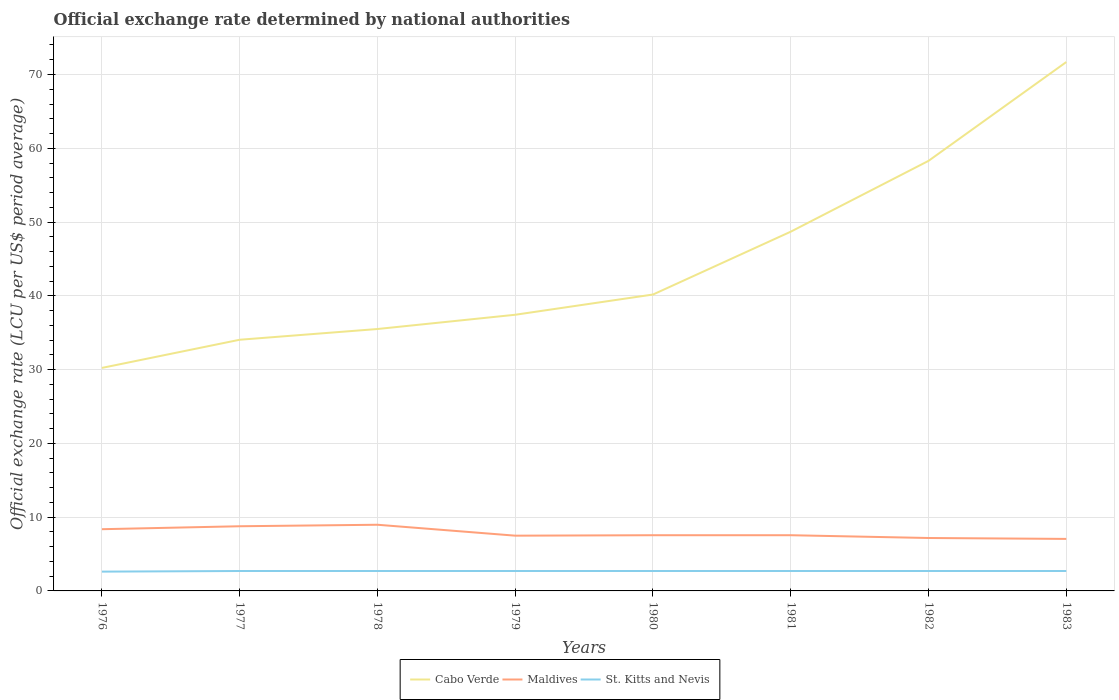Does the line corresponding to Cabo Verde intersect with the line corresponding to St. Kitts and Nevis?
Keep it short and to the point. No. Is the number of lines equal to the number of legend labels?
Your response must be concise. Yes. Across all years, what is the maximum official exchange rate in Cabo Verde?
Your answer should be very brief. 30.23. In which year was the official exchange rate in St. Kitts and Nevis maximum?
Make the answer very short. 1976. What is the total official exchange rate in St. Kitts and Nevis in the graph?
Your response must be concise. 0. What is the difference between the highest and the second highest official exchange rate in Maldives?
Ensure brevity in your answer.  1.92. What is the difference between the highest and the lowest official exchange rate in Maldives?
Offer a very short reply. 3. Are the values on the major ticks of Y-axis written in scientific E-notation?
Keep it short and to the point. No. Does the graph contain grids?
Make the answer very short. Yes. How many legend labels are there?
Provide a short and direct response. 3. What is the title of the graph?
Provide a short and direct response. Official exchange rate determined by national authorities. What is the label or title of the Y-axis?
Provide a succinct answer. Official exchange rate (LCU per US$ period average). What is the Official exchange rate (LCU per US$ period average) of Cabo Verde in 1976?
Give a very brief answer. 30.23. What is the Official exchange rate (LCU per US$ period average) in Maldives in 1976?
Keep it short and to the point. 8.36. What is the Official exchange rate (LCU per US$ period average) in St. Kitts and Nevis in 1976?
Offer a very short reply. 2.61. What is the Official exchange rate (LCU per US$ period average) of Cabo Verde in 1977?
Provide a short and direct response. 34.05. What is the Official exchange rate (LCU per US$ period average) in Maldives in 1977?
Provide a short and direct response. 8.77. What is the Official exchange rate (LCU per US$ period average) of Cabo Verde in 1978?
Offer a very short reply. 35.5. What is the Official exchange rate (LCU per US$ period average) in Maldives in 1978?
Your answer should be very brief. 8.97. What is the Official exchange rate (LCU per US$ period average) of Cabo Verde in 1979?
Keep it short and to the point. 37.43. What is the Official exchange rate (LCU per US$ period average) of Maldives in 1979?
Provide a short and direct response. 7.49. What is the Official exchange rate (LCU per US$ period average) of St. Kitts and Nevis in 1979?
Offer a very short reply. 2.7. What is the Official exchange rate (LCU per US$ period average) in Cabo Verde in 1980?
Your answer should be very brief. 40.17. What is the Official exchange rate (LCU per US$ period average) in Maldives in 1980?
Provide a succinct answer. 7.55. What is the Official exchange rate (LCU per US$ period average) of Cabo Verde in 1981?
Provide a succinct answer. 48.69. What is the Official exchange rate (LCU per US$ period average) in Maldives in 1981?
Make the answer very short. 7.55. What is the Official exchange rate (LCU per US$ period average) in St. Kitts and Nevis in 1981?
Your answer should be compact. 2.7. What is the Official exchange rate (LCU per US$ period average) of Cabo Verde in 1982?
Your answer should be compact. 58.29. What is the Official exchange rate (LCU per US$ period average) in Maldives in 1982?
Make the answer very short. 7.17. What is the Official exchange rate (LCU per US$ period average) of St. Kitts and Nevis in 1982?
Keep it short and to the point. 2.7. What is the Official exchange rate (LCU per US$ period average) in Cabo Verde in 1983?
Your response must be concise. 71.69. What is the Official exchange rate (LCU per US$ period average) in Maldives in 1983?
Provide a short and direct response. 7.05. What is the Official exchange rate (LCU per US$ period average) of St. Kitts and Nevis in 1983?
Keep it short and to the point. 2.7. Across all years, what is the maximum Official exchange rate (LCU per US$ period average) of Cabo Verde?
Give a very brief answer. 71.69. Across all years, what is the maximum Official exchange rate (LCU per US$ period average) in Maldives?
Provide a short and direct response. 8.97. Across all years, what is the minimum Official exchange rate (LCU per US$ period average) in Cabo Verde?
Give a very brief answer. 30.23. Across all years, what is the minimum Official exchange rate (LCU per US$ period average) in Maldives?
Provide a succinct answer. 7.05. Across all years, what is the minimum Official exchange rate (LCU per US$ period average) of St. Kitts and Nevis?
Give a very brief answer. 2.61. What is the total Official exchange rate (LCU per US$ period average) in Cabo Verde in the graph?
Ensure brevity in your answer.  356.06. What is the total Official exchange rate (LCU per US$ period average) of Maldives in the graph?
Your answer should be compact. 62.91. What is the total Official exchange rate (LCU per US$ period average) in St. Kitts and Nevis in the graph?
Make the answer very short. 21.51. What is the difference between the Official exchange rate (LCU per US$ period average) in Cabo Verde in 1976 and that in 1977?
Keep it short and to the point. -3.82. What is the difference between the Official exchange rate (LCU per US$ period average) of Maldives in 1976 and that in 1977?
Ensure brevity in your answer.  -0.4. What is the difference between the Official exchange rate (LCU per US$ period average) in St. Kitts and Nevis in 1976 and that in 1977?
Offer a terse response. -0.09. What is the difference between the Official exchange rate (LCU per US$ period average) in Cabo Verde in 1976 and that in 1978?
Your answer should be very brief. -5.27. What is the difference between the Official exchange rate (LCU per US$ period average) of Maldives in 1976 and that in 1978?
Provide a succinct answer. -0.6. What is the difference between the Official exchange rate (LCU per US$ period average) of St. Kitts and Nevis in 1976 and that in 1978?
Give a very brief answer. -0.09. What is the difference between the Official exchange rate (LCU per US$ period average) of Cabo Verde in 1976 and that in 1979?
Offer a very short reply. -7.2. What is the difference between the Official exchange rate (LCU per US$ period average) of Maldives in 1976 and that in 1979?
Make the answer very short. 0.88. What is the difference between the Official exchange rate (LCU per US$ period average) of St. Kitts and Nevis in 1976 and that in 1979?
Your response must be concise. -0.09. What is the difference between the Official exchange rate (LCU per US$ period average) in Cabo Verde in 1976 and that in 1980?
Your response must be concise. -9.95. What is the difference between the Official exchange rate (LCU per US$ period average) in Maldives in 1976 and that in 1980?
Provide a succinct answer. 0.81. What is the difference between the Official exchange rate (LCU per US$ period average) of St. Kitts and Nevis in 1976 and that in 1980?
Make the answer very short. -0.09. What is the difference between the Official exchange rate (LCU per US$ period average) of Cabo Verde in 1976 and that in 1981?
Your answer should be very brief. -18.47. What is the difference between the Official exchange rate (LCU per US$ period average) in Maldives in 1976 and that in 1981?
Offer a very short reply. 0.81. What is the difference between the Official exchange rate (LCU per US$ period average) of St. Kitts and Nevis in 1976 and that in 1981?
Ensure brevity in your answer.  -0.09. What is the difference between the Official exchange rate (LCU per US$ period average) of Cabo Verde in 1976 and that in 1982?
Make the answer very short. -28.06. What is the difference between the Official exchange rate (LCU per US$ period average) of Maldives in 1976 and that in 1982?
Provide a short and direct response. 1.19. What is the difference between the Official exchange rate (LCU per US$ period average) of St. Kitts and Nevis in 1976 and that in 1982?
Offer a terse response. -0.09. What is the difference between the Official exchange rate (LCU per US$ period average) in Cabo Verde in 1976 and that in 1983?
Provide a short and direct response. -41.46. What is the difference between the Official exchange rate (LCU per US$ period average) in Maldives in 1976 and that in 1983?
Your response must be concise. 1.31. What is the difference between the Official exchange rate (LCU per US$ period average) in St. Kitts and Nevis in 1976 and that in 1983?
Your answer should be very brief. -0.09. What is the difference between the Official exchange rate (LCU per US$ period average) in Cabo Verde in 1977 and that in 1978?
Give a very brief answer. -1.45. What is the difference between the Official exchange rate (LCU per US$ period average) of Maldives in 1977 and that in 1978?
Make the answer very short. -0.2. What is the difference between the Official exchange rate (LCU per US$ period average) of St. Kitts and Nevis in 1977 and that in 1978?
Keep it short and to the point. 0. What is the difference between the Official exchange rate (LCU per US$ period average) in Cabo Verde in 1977 and that in 1979?
Provide a succinct answer. -3.39. What is the difference between the Official exchange rate (LCU per US$ period average) of Maldives in 1977 and that in 1979?
Your answer should be compact. 1.28. What is the difference between the Official exchange rate (LCU per US$ period average) in Cabo Verde in 1977 and that in 1980?
Your answer should be compact. -6.13. What is the difference between the Official exchange rate (LCU per US$ period average) in Maldives in 1977 and that in 1980?
Ensure brevity in your answer.  1.22. What is the difference between the Official exchange rate (LCU per US$ period average) in St. Kitts and Nevis in 1977 and that in 1980?
Your answer should be compact. 0. What is the difference between the Official exchange rate (LCU per US$ period average) of Cabo Verde in 1977 and that in 1981?
Your response must be concise. -14.65. What is the difference between the Official exchange rate (LCU per US$ period average) in Maldives in 1977 and that in 1981?
Give a very brief answer. 1.22. What is the difference between the Official exchange rate (LCU per US$ period average) of St. Kitts and Nevis in 1977 and that in 1981?
Keep it short and to the point. 0. What is the difference between the Official exchange rate (LCU per US$ period average) in Cabo Verde in 1977 and that in 1982?
Provide a short and direct response. -24.25. What is the difference between the Official exchange rate (LCU per US$ period average) in Maldives in 1977 and that in 1982?
Give a very brief answer. 1.59. What is the difference between the Official exchange rate (LCU per US$ period average) of Cabo Verde in 1977 and that in 1983?
Provide a short and direct response. -37.64. What is the difference between the Official exchange rate (LCU per US$ period average) in Maldives in 1977 and that in 1983?
Your answer should be very brief. 1.72. What is the difference between the Official exchange rate (LCU per US$ period average) in Cabo Verde in 1978 and that in 1979?
Offer a terse response. -1.93. What is the difference between the Official exchange rate (LCU per US$ period average) in Maldives in 1978 and that in 1979?
Provide a short and direct response. 1.48. What is the difference between the Official exchange rate (LCU per US$ period average) of St. Kitts and Nevis in 1978 and that in 1979?
Your response must be concise. 0. What is the difference between the Official exchange rate (LCU per US$ period average) in Cabo Verde in 1978 and that in 1980?
Keep it short and to the point. -4.67. What is the difference between the Official exchange rate (LCU per US$ period average) of Maldives in 1978 and that in 1980?
Your answer should be compact. 1.42. What is the difference between the Official exchange rate (LCU per US$ period average) of Cabo Verde in 1978 and that in 1981?
Offer a terse response. -13.19. What is the difference between the Official exchange rate (LCU per US$ period average) of Maldives in 1978 and that in 1981?
Provide a short and direct response. 1.42. What is the difference between the Official exchange rate (LCU per US$ period average) in St. Kitts and Nevis in 1978 and that in 1981?
Your answer should be compact. 0. What is the difference between the Official exchange rate (LCU per US$ period average) of Cabo Verde in 1978 and that in 1982?
Offer a very short reply. -22.79. What is the difference between the Official exchange rate (LCU per US$ period average) of Maldives in 1978 and that in 1982?
Your response must be concise. 1.8. What is the difference between the Official exchange rate (LCU per US$ period average) in St. Kitts and Nevis in 1978 and that in 1982?
Offer a terse response. 0. What is the difference between the Official exchange rate (LCU per US$ period average) of Cabo Verde in 1978 and that in 1983?
Give a very brief answer. -36.19. What is the difference between the Official exchange rate (LCU per US$ period average) of Maldives in 1978 and that in 1983?
Your answer should be compact. 1.92. What is the difference between the Official exchange rate (LCU per US$ period average) in St. Kitts and Nevis in 1978 and that in 1983?
Your response must be concise. 0. What is the difference between the Official exchange rate (LCU per US$ period average) in Cabo Verde in 1979 and that in 1980?
Ensure brevity in your answer.  -2.74. What is the difference between the Official exchange rate (LCU per US$ period average) of Maldives in 1979 and that in 1980?
Your answer should be compact. -0.06. What is the difference between the Official exchange rate (LCU per US$ period average) of Cabo Verde in 1979 and that in 1981?
Keep it short and to the point. -11.26. What is the difference between the Official exchange rate (LCU per US$ period average) in Maldives in 1979 and that in 1981?
Your response must be concise. -0.06. What is the difference between the Official exchange rate (LCU per US$ period average) of St. Kitts and Nevis in 1979 and that in 1981?
Provide a succinct answer. 0. What is the difference between the Official exchange rate (LCU per US$ period average) of Cabo Verde in 1979 and that in 1982?
Provide a short and direct response. -20.86. What is the difference between the Official exchange rate (LCU per US$ period average) of Maldives in 1979 and that in 1982?
Keep it short and to the point. 0.31. What is the difference between the Official exchange rate (LCU per US$ period average) in St. Kitts and Nevis in 1979 and that in 1982?
Keep it short and to the point. 0. What is the difference between the Official exchange rate (LCU per US$ period average) in Cabo Verde in 1979 and that in 1983?
Provide a succinct answer. -34.25. What is the difference between the Official exchange rate (LCU per US$ period average) of Maldives in 1979 and that in 1983?
Your answer should be very brief. 0.44. What is the difference between the Official exchange rate (LCU per US$ period average) of Cabo Verde in 1980 and that in 1981?
Ensure brevity in your answer.  -8.52. What is the difference between the Official exchange rate (LCU per US$ period average) of Maldives in 1980 and that in 1981?
Make the answer very short. 0. What is the difference between the Official exchange rate (LCU per US$ period average) of Cabo Verde in 1980 and that in 1982?
Provide a succinct answer. -18.12. What is the difference between the Official exchange rate (LCU per US$ period average) in Maldives in 1980 and that in 1982?
Your answer should be very brief. 0.38. What is the difference between the Official exchange rate (LCU per US$ period average) of St. Kitts and Nevis in 1980 and that in 1982?
Offer a terse response. 0. What is the difference between the Official exchange rate (LCU per US$ period average) in Cabo Verde in 1980 and that in 1983?
Your response must be concise. -31.51. What is the difference between the Official exchange rate (LCU per US$ period average) in Cabo Verde in 1981 and that in 1982?
Keep it short and to the point. -9.6. What is the difference between the Official exchange rate (LCU per US$ period average) of Maldives in 1981 and that in 1982?
Offer a terse response. 0.38. What is the difference between the Official exchange rate (LCU per US$ period average) of Cabo Verde in 1981 and that in 1983?
Keep it short and to the point. -22.99. What is the difference between the Official exchange rate (LCU per US$ period average) of Maldives in 1981 and that in 1983?
Give a very brief answer. 0.5. What is the difference between the Official exchange rate (LCU per US$ period average) in St. Kitts and Nevis in 1981 and that in 1983?
Make the answer very short. 0. What is the difference between the Official exchange rate (LCU per US$ period average) in Cabo Verde in 1982 and that in 1983?
Give a very brief answer. -13.39. What is the difference between the Official exchange rate (LCU per US$ period average) of Maldives in 1982 and that in 1983?
Your answer should be compact. 0.12. What is the difference between the Official exchange rate (LCU per US$ period average) of St. Kitts and Nevis in 1982 and that in 1983?
Your response must be concise. 0. What is the difference between the Official exchange rate (LCU per US$ period average) in Cabo Verde in 1976 and the Official exchange rate (LCU per US$ period average) in Maldives in 1977?
Keep it short and to the point. 21.46. What is the difference between the Official exchange rate (LCU per US$ period average) of Cabo Verde in 1976 and the Official exchange rate (LCU per US$ period average) of St. Kitts and Nevis in 1977?
Make the answer very short. 27.53. What is the difference between the Official exchange rate (LCU per US$ period average) in Maldives in 1976 and the Official exchange rate (LCU per US$ period average) in St. Kitts and Nevis in 1977?
Your answer should be compact. 5.66. What is the difference between the Official exchange rate (LCU per US$ period average) in Cabo Verde in 1976 and the Official exchange rate (LCU per US$ period average) in Maldives in 1978?
Your answer should be very brief. 21.26. What is the difference between the Official exchange rate (LCU per US$ period average) of Cabo Verde in 1976 and the Official exchange rate (LCU per US$ period average) of St. Kitts and Nevis in 1978?
Offer a terse response. 27.53. What is the difference between the Official exchange rate (LCU per US$ period average) in Maldives in 1976 and the Official exchange rate (LCU per US$ period average) in St. Kitts and Nevis in 1978?
Your answer should be very brief. 5.66. What is the difference between the Official exchange rate (LCU per US$ period average) in Cabo Verde in 1976 and the Official exchange rate (LCU per US$ period average) in Maldives in 1979?
Make the answer very short. 22.74. What is the difference between the Official exchange rate (LCU per US$ period average) in Cabo Verde in 1976 and the Official exchange rate (LCU per US$ period average) in St. Kitts and Nevis in 1979?
Ensure brevity in your answer.  27.53. What is the difference between the Official exchange rate (LCU per US$ period average) of Maldives in 1976 and the Official exchange rate (LCU per US$ period average) of St. Kitts and Nevis in 1979?
Ensure brevity in your answer.  5.66. What is the difference between the Official exchange rate (LCU per US$ period average) in Cabo Verde in 1976 and the Official exchange rate (LCU per US$ period average) in Maldives in 1980?
Offer a terse response. 22.68. What is the difference between the Official exchange rate (LCU per US$ period average) in Cabo Verde in 1976 and the Official exchange rate (LCU per US$ period average) in St. Kitts and Nevis in 1980?
Your response must be concise. 27.53. What is the difference between the Official exchange rate (LCU per US$ period average) in Maldives in 1976 and the Official exchange rate (LCU per US$ period average) in St. Kitts and Nevis in 1980?
Offer a very short reply. 5.66. What is the difference between the Official exchange rate (LCU per US$ period average) of Cabo Verde in 1976 and the Official exchange rate (LCU per US$ period average) of Maldives in 1981?
Provide a short and direct response. 22.68. What is the difference between the Official exchange rate (LCU per US$ period average) of Cabo Verde in 1976 and the Official exchange rate (LCU per US$ period average) of St. Kitts and Nevis in 1981?
Offer a terse response. 27.53. What is the difference between the Official exchange rate (LCU per US$ period average) of Maldives in 1976 and the Official exchange rate (LCU per US$ period average) of St. Kitts and Nevis in 1981?
Make the answer very short. 5.66. What is the difference between the Official exchange rate (LCU per US$ period average) in Cabo Verde in 1976 and the Official exchange rate (LCU per US$ period average) in Maldives in 1982?
Ensure brevity in your answer.  23.06. What is the difference between the Official exchange rate (LCU per US$ period average) of Cabo Verde in 1976 and the Official exchange rate (LCU per US$ period average) of St. Kitts and Nevis in 1982?
Provide a succinct answer. 27.53. What is the difference between the Official exchange rate (LCU per US$ period average) of Maldives in 1976 and the Official exchange rate (LCU per US$ period average) of St. Kitts and Nevis in 1982?
Your response must be concise. 5.66. What is the difference between the Official exchange rate (LCU per US$ period average) of Cabo Verde in 1976 and the Official exchange rate (LCU per US$ period average) of Maldives in 1983?
Ensure brevity in your answer.  23.18. What is the difference between the Official exchange rate (LCU per US$ period average) of Cabo Verde in 1976 and the Official exchange rate (LCU per US$ period average) of St. Kitts and Nevis in 1983?
Offer a very short reply. 27.53. What is the difference between the Official exchange rate (LCU per US$ period average) in Maldives in 1976 and the Official exchange rate (LCU per US$ period average) in St. Kitts and Nevis in 1983?
Keep it short and to the point. 5.66. What is the difference between the Official exchange rate (LCU per US$ period average) of Cabo Verde in 1977 and the Official exchange rate (LCU per US$ period average) of Maldives in 1978?
Ensure brevity in your answer.  25.08. What is the difference between the Official exchange rate (LCU per US$ period average) of Cabo Verde in 1977 and the Official exchange rate (LCU per US$ period average) of St. Kitts and Nevis in 1978?
Provide a succinct answer. 31.35. What is the difference between the Official exchange rate (LCU per US$ period average) in Maldives in 1977 and the Official exchange rate (LCU per US$ period average) in St. Kitts and Nevis in 1978?
Your answer should be very brief. 6.07. What is the difference between the Official exchange rate (LCU per US$ period average) of Cabo Verde in 1977 and the Official exchange rate (LCU per US$ period average) of Maldives in 1979?
Keep it short and to the point. 26.56. What is the difference between the Official exchange rate (LCU per US$ period average) in Cabo Verde in 1977 and the Official exchange rate (LCU per US$ period average) in St. Kitts and Nevis in 1979?
Give a very brief answer. 31.35. What is the difference between the Official exchange rate (LCU per US$ period average) in Maldives in 1977 and the Official exchange rate (LCU per US$ period average) in St. Kitts and Nevis in 1979?
Provide a succinct answer. 6.07. What is the difference between the Official exchange rate (LCU per US$ period average) in Cabo Verde in 1977 and the Official exchange rate (LCU per US$ period average) in Maldives in 1980?
Give a very brief answer. 26.5. What is the difference between the Official exchange rate (LCU per US$ period average) in Cabo Verde in 1977 and the Official exchange rate (LCU per US$ period average) in St. Kitts and Nevis in 1980?
Ensure brevity in your answer.  31.35. What is the difference between the Official exchange rate (LCU per US$ period average) in Maldives in 1977 and the Official exchange rate (LCU per US$ period average) in St. Kitts and Nevis in 1980?
Provide a succinct answer. 6.07. What is the difference between the Official exchange rate (LCU per US$ period average) of Cabo Verde in 1977 and the Official exchange rate (LCU per US$ period average) of Maldives in 1981?
Give a very brief answer. 26.5. What is the difference between the Official exchange rate (LCU per US$ period average) of Cabo Verde in 1977 and the Official exchange rate (LCU per US$ period average) of St. Kitts and Nevis in 1981?
Make the answer very short. 31.35. What is the difference between the Official exchange rate (LCU per US$ period average) of Maldives in 1977 and the Official exchange rate (LCU per US$ period average) of St. Kitts and Nevis in 1981?
Offer a very short reply. 6.07. What is the difference between the Official exchange rate (LCU per US$ period average) in Cabo Verde in 1977 and the Official exchange rate (LCU per US$ period average) in Maldives in 1982?
Your answer should be very brief. 26.87. What is the difference between the Official exchange rate (LCU per US$ period average) in Cabo Verde in 1977 and the Official exchange rate (LCU per US$ period average) in St. Kitts and Nevis in 1982?
Give a very brief answer. 31.35. What is the difference between the Official exchange rate (LCU per US$ period average) in Maldives in 1977 and the Official exchange rate (LCU per US$ period average) in St. Kitts and Nevis in 1982?
Provide a succinct answer. 6.07. What is the difference between the Official exchange rate (LCU per US$ period average) of Cabo Verde in 1977 and the Official exchange rate (LCU per US$ period average) of Maldives in 1983?
Make the answer very short. 27. What is the difference between the Official exchange rate (LCU per US$ period average) in Cabo Verde in 1977 and the Official exchange rate (LCU per US$ period average) in St. Kitts and Nevis in 1983?
Keep it short and to the point. 31.35. What is the difference between the Official exchange rate (LCU per US$ period average) of Maldives in 1977 and the Official exchange rate (LCU per US$ period average) of St. Kitts and Nevis in 1983?
Keep it short and to the point. 6.07. What is the difference between the Official exchange rate (LCU per US$ period average) of Cabo Verde in 1978 and the Official exchange rate (LCU per US$ period average) of Maldives in 1979?
Offer a terse response. 28.01. What is the difference between the Official exchange rate (LCU per US$ period average) in Cabo Verde in 1978 and the Official exchange rate (LCU per US$ period average) in St. Kitts and Nevis in 1979?
Provide a succinct answer. 32.8. What is the difference between the Official exchange rate (LCU per US$ period average) in Maldives in 1978 and the Official exchange rate (LCU per US$ period average) in St. Kitts and Nevis in 1979?
Keep it short and to the point. 6.27. What is the difference between the Official exchange rate (LCU per US$ period average) in Cabo Verde in 1978 and the Official exchange rate (LCU per US$ period average) in Maldives in 1980?
Your response must be concise. 27.95. What is the difference between the Official exchange rate (LCU per US$ period average) in Cabo Verde in 1978 and the Official exchange rate (LCU per US$ period average) in St. Kitts and Nevis in 1980?
Provide a succinct answer. 32.8. What is the difference between the Official exchange rate (LCU per US$ period average) in Maldives in 1978 and the Official exchange rate (LCU per US$ period average) in St. Kitts and Nevis in 1980?
Your answer should be very brief. 6.27. What is the difference between the Official exchange rate (LCU per US$ period average) of Cabo Verde in 1978 and the Official exchange rate (LCU per US$ period average) of Maldives in 1981?
Offer a very short reply. 27.95. What is the difference between the Official exchange rate (LCU per US$ period average) of Cabo Verde in 1978 and the Official exchange rate (LCU per US$ period average) of St. Kitts and Nevis in 1981?
Offer a very short reply. 32.8. What is the difference between the Official exchange rate (LCU per US$ period average) in Maldives in 1978 and the Official exchange rate (LCU per US$ period average) in St. Kitts and Nevis in 1981?
Your response must be concise. 6.27. What is the difference between the Official exchange rate (LCU per US$ period average) of Cabo Verde in 1978 and the Official exchange rate (LCU per US$ period average) of Maldives in 1982?
Your answer should be compact. 28.33. What is the difference between the Official exchange rate (LCU per US$ period average) in Cabo Verde in 1978 and the Official exchange rate (LCU per US$ period average) in St. Kitts and Nevis in 1982?
Provide a succinct answer. 32.8. What is the difference between the Official exchange rate (LCU per US$ period average) of Maldives in 1978 and the Official exchange rate (LCU per US$ period average) of St. Kitts and Nevis in 1982?
Your answer should be very brief. 6.27. What is the difference between the Official exchange rate (LCU per US$ period average) of Cabo Verde in 1978 and the Official exchange rate (LCU per US$ period average) of Maldives in 1983?
Ensure brevity in your answer.  28.45. What is the difference between the Official exchange rate (LCU per US$ period average) of Cabo Verde in 1978 and the Official exchange rate (LCU per US$ period average) of St. Kitts and Nevis in 1983?
Your response must be concise. 32.8. What is the difference between the Official exchange rate (LCU per US$ period average) of Maldives in 1978 and the Official exchange rate (LCU per US$ period average) of St. Kitts and Nevis in 1983?
Your answer should be very brief. 6.27. What is the difference between the Official exchange rate (LCU per US$ period average) of Cabo Verde in 1979 and the Official exchange rate (LCU per US$ period average) of Maldives in 1980?
Your answer should be very brief. 29.88. What is the difference between the Official exchange rate (LCU per US$ period average) in Cabo Verde in 1979 and the Official exchange rate (LCU per US$ period average) in St. Kitts and Nevis in 1980?
Make the answer very short. 34.73. What is the difference between the Official exchange rate (LCU per US$ period average) in Maldives in 1979 and the Official exchange rate (LCU per US$ period average) in St. Kitts and Nevis in 1980?
Offer a very short reply. 4.79. What is the difference between the Official exchange rate (LCU per US$ period average) of Cabo Verde in 1979 and the Official exchange rate (LCU per US$ period average) of Maldives in 1981?
Make the answer very short. 29.88. What is the difference between the Official exchange rate (LCU per US$ period average) of Cabo Verde in 1979 and the Official exchange rate (LCU per US$ period average) of St. Kitts and Nevis in 1981?
Your answer should be very brief. 34.73. What is the difference between the Official exchange rate (LCU per US$ period average) in Maldives in 1979 and the Official exchange rate (LCU per US$ period average) in St. Kitts and Nevis in 1981?
Ensure brevity in your answer.  4.79. What is the difference between the Official exchange rate (LCU per US$ period average) in Cabo Verde in 1979 and the Official exchange rate (LCU per US$ period average) in Maldives in 1982?
Your answer should be compact. 30.26. What is the difference between the Official exchange rate (LCU per US$ period average) of Cabo Verde in 1979 and the Official exchange rate (LCU per US$ period average) of St. Kitts and Nevis in 1982?
Your answer should be compact. 34.73. What is the difference between the Official exchange rate (LCU per US$ period average) of Maldives in 1979 and the Official exchange rate (LCU per US$ period average) of St. Kitts and Nevis in 1982?
Make the answer very short. 4.79. What is the difference between the Official exchange rate (LCU per US$ period average) of Cabo Verde in 1979 and the Official exchange rate (LCU per US$ period average) of Maldives in 1983?
Your response must be concise. 30.38. What is the difference between the Official exchange rate (LCU per US$ period average) in Cabo Verde in 1979 and the Official exchange rate (LCU per US$ period average) in St. Kitts and Nevis in 1983?
Ensure brevity in your answer.  34.73. What is the difference between the Official exchange rate (LCU per US$ period average) of Maldives in 1979 and the Official exchange rate (LCU per US$ period average) of St. Kitts and Nevis in 1983?
Your answer should be very brief. 4.79. What is the difference between the Official exchange rate (LCU per US$ period average) of Cabo Verde in 1980 and the Official exchange rate (LCU per US$ period average) of Maldives in 1981?
Give a very brief answer. 32.62. What is the difference between the Official exchange rate (LCU per US$ period average) in Cabo Verde in 1980 and the Official exchange rate (LCU per US$ period average) in St. Kitts and Nevis in 1981?
Make the answer very short. 37.47. What is the difference between the Official exchange rate (LCU per US$ period average) in Maldives in 1980 and the Official exchange rate (LCU per US$ period average) in St. Kitts and Nevis in 1981?
Give a very brief answer. 4.85. What is the difference between the Official exchange rate (LCU per US$ period average) in Cabo Verde in 1980 and the Official exchange rate (LCU per US$ period average) in Maldives in 1982?
Your answer should be very brief. 33. What is the difference between the Official exchange rate (LCU per US$ period average) of Cabo Verde in 1980 and the Official exchange rate (LCU per US$ period average) of St. Kitts and Nevis in 1982?
Provide a succinct answer. 37.47. What is the difference between the Official exchange rate (LCU per US$ period average) of Maldives in 1980 and the Official exchange rate (LCU per US$ period average) of St. Kitts and Nevis in 1982?
Keep it short and to the point. 4.85. What is the difference between the Official exchange rate (LCU per US$ period average) in Cabo Verde in 1980 and the Official exchange rate (LCU per US$ period average) in Maldives in 1983?
Your answer should be compact. 33.12. What is the difference between the Official exchange rate (LCU per US$ period average) of Cabo Verde in 1980 and the Official exchange rate (LCU per US$ period average) of St. Kitts and Nevis in 1983?
Make the answer very short. 37.47. What is the difference between the Official exchange rate (LCU per US$ period average) of Maldives in 1980 and the Official exchange rate (LCU per US$ period average) of St. Kitts and Nevis in 1983?
Give a very brief answer. 4.85. What is the difference between the Official exchange rate (LCU per US$ period average) of Cabo Verde in 1981 and the Official exchange rate (LCU per US$ period average) of Maldives in 1982?
Your response must be concise. 41.52. What is the difference between the Official exchange rate (LCU per US$ period average) in Cabo Verde in 1981 and the Official exchange rate (LCU per US$ period average) in St. Kitts and Nevis in 1982?
Your answer should be compact. 45.99. What is the difference between the Official exchange rate (LCU per US$ period average) of Maldives in 1981 and the Official exchange rate (LCU per US$ period average) of St. Kitts and Nevis in 1982?
Your response must be concise. 4.85. What is the difference between the Official exchange rate (LCU per US$ period average) of Cabo Verde in 1981 and the Official exchange rate (LCU per US$ period average) of Maldives in 1983?
Your response must be concise. 41.64. What is the difference between the Official exchange rate (LCU per US$ period average) in Cabo Verde in 1981 and the Official exchange rate (LCU per US$ period average) in St. Kitts and Nevis in 1983?
Offer a very short reply. 45.99. What is the difference between the Official exchange rate (LCU per US$ period average) in Maldives in 1981 and the Official exchange rate (LCU per US$ period average) in St. Kitts and Nevis in 1983?
Ensure brevity in your answer.  4.85. What is the difference between the Official exchange rate (LCU per US$ period average) of Cabo Verde in 1982 and the Official exchange rate (LCU per US$ period average) of Maldives in 1983?
Your answer should be very brief. 51.24. What is the difference between the Official exchange rate (LCU per US$ period average) of Cabo Verde in 1982 and the Official exchange rate (LCU per US$ period average) of St. Kitts and Nevis in 1983?
Give a very brief answer. 55.59. What is the difference between the Official exchange rate (LCU per US$ period average) in Maldives in 1982 and the Official exchange rate (LCU per US$ period average) in St. Kitts and Nevis in 1983?
Your answer should be compact. 4.47. What is the average Official exchange rate (LCU per US$ period average) of Cabo Verde per year?
Ensure brevity in your answer.  44.51. What is the average Official exchange rate (LCU per US$ period average) of Maldives per year?
Offer a terse response. 7.86. What is the average Official exchange rate (LCU per US$ period average) in St. Kitts and Nevis per year?
Make the answer very short. 2.69. In the year 1976, what is the difference between the Official exchange rate (LCU per US$ period average) of Cabo Verde and Official exchange rate (LCU per US$ period average) of Maldives?
Make the answer very short. 21.86. In the year 1976, what is the difference between the Official exchange rate (LCU per US$ period average) of Cabo Verde and Official exchange rate (LCU per US$ period average) of St. Kitts and Nevis?
Offer a terse response. 27.61. In the year 1976, what is the difference between the Official exchange rate (LCU per US$ period average) of Maldives and Official exchange rate (LCU per US$ period average) of St. Kitts and Nevis?
Make the answer very short. 5.75. In the year 1977, what is the difference between the Official exchange rate (LCU per US$ period average) of Cabo Verde and Official exchange rate (LCU per US$ period average) of Maldives?
Provide a succinct answer. 25.28. In the year 1977, what is the difference between the Official exchange rate (LCU per US$ period average) in Cabo Verde and Official exchange rate (LCU per US$ period average) in St. Kitts and Nevis?
Your answer should be very brief. 31.35. In the year 1977, what is the difference between the Official exchange rate (LCU per US$ period average) in Maldives and Official exchange rate (LCU per US$ period average) in St. Kitts and Nevis?
Offer a terse response. 6.07. In the year 1978, what is the difference between the Official exchange rate (LCU per US$ period average) of Cabo Verde and Official exchange rate (LCU per US$ period average) of Maldives?
Your answer should be compact. 26.53. In the year 1978, what is the difference between the Official exchange rate (LCU per US$ period average) of Cabo Verde and Official exchange rate (LCU per US$ period average) of St. Kitts and Nevis?
Offer a very short reply. 32.8. In the year 1978, what is the difference between the Official exchange rate (LCU per US$ period average) in Maldives and Official exchange rate (LCU per US$ period average) in St. Kitts and Nevis?
Provide a short and direct response. 6.27. In the year 1979, what is the difference between the Official exchange rate (LCU per US$ period average) in Cabo Verde and Official exchange rate (LCU per US$ period average) in Maldives?
Your answer should be compact. 29.94. In the year 1979, what is the difference between the Official exchange rate (LCU per US$ period average) in Cabo Verde and Official exchange rate (LCU per US$ period average) in St. Kitts and Nevis?
Give a very brief answer. 34.73. In the year 1979, what is the difference between the Official exchange rate (LCU per US$ period average) in Maldives and Official exchange rate (LCU per US$ period average) in St. Kitts and Nevis?
Your answer should be compact. 4.79. In the year 1980, what is the difference between the Official exchange rate (LCU per US$ period average) in Cabo Verde and Official exchange rate (LCU per US$ period average) in Maldives?
Provide a succinct answer. 32.62. In the year 1980, what is the difference between the Official exchange rate (LCU per US$ period average) of Cabo Verde and Official exchange rate (LCU per US$ period average) of St. Kitts and Nevis?
Make the answer very short. 37.47. In the year 1980, what is the difference between the Official exchange rate (LCU per US$ period average) in Maldives and Official exchange rate (LCU per US$ period average) in St. Kitts and Nevis?
Your answer should be compact. 4.85. In the year 1981, what is the difference between the Official exchange rate (LCU per US$ period average) of Cabo Verde and Official exchange rate (LCU per US$ period average) of Maldives?
Make the answer very short. 41.14. In the year 1981, what is the difference between the Official exchange rate (LCU per US$ period average) of Cabo Verde and Official exchange rate (LCU per US$ period average) of St. Kitts and Nevis?
Your response must be concise. 45.99. In the year 1981, what is the difference between the Official exchange rate (LCU per US$ period average) in Maldives and Official exchange rate (LCU per US$ period average) in St. Kitts and Nevis?
Keep it short and to the point. 4.85. In the year 1982, what is the difference between the Official exchange rate (LCU per US$ period average) in Cabo Verde and Official exchange rate (LCU per US$ period average) in Maldives?
Give a very brief answer. 51.12. In the year 1982, what is the difference between the Official exchange rate (LCU per US$ period average) in Cabo Verde and Official exchange rate (LCU per US$ period average) in St. Kitts and Nevis?
Keep it short and to the point. 55.59. In the year 1982, what is the difference between the Official exchange rate (LCU per US$ period average) in Maldives and Official exchange rate (LCU per US$ period average) in St. Kitts and Nevis?
Give a very brief answer. 4.47. In the year 1983, what is the difference between the Official exchange rate (LCU per US$ period average) of Cabo Verde and Official exchange rate (LCU per US$ period average) of Maldives?
Your response must be concise. 64.64. In the year 1983, what is the difference between the Official exchange rate (LCU per US$ period average) in Cabo Verde and Official exchange rate (LCU per US$ period average) in St. Kitts and Nevis?
Make the answer very short. 68.99. In the year 1983, what is the difference between the Official exchange rate (LCU per US$ period average) in Maldives and Official exchange rate (LCU per US$ period average) in St. Kitts and Nevis?
Your answer should be very brief. 4.35. What is the ratio of the Official exchange rate (LCU per US$ period average) in Cabo Verde in 1976 to that in 1977?
Keep it short and to the point. 0.89. What is the ratio of the Official exchange rate (LCU per US$ period average) in Maldives in 1976 to that in 1977?
Your response must be concise. 0.95. What is the ratio of the Official exchange rate (LCU per US$ period average) of St. Kitts and Nevis in 1976 to that in 1977?
Keep it short and to the point. 0.97. What is the ratio of the Official exchange rate (LCU per US$ period average) in Cabo Verde in 1976 to that in 1978?
Give a very brief answer. 0.85. What is the ratio of the Official exchange rate (LCU per US$ period average) in Maldives in 1976 to that in 1978?
Offer a terse response. 0.93. What is the ratio of the Official exchange rate (LCU per US$ period average) of St. Kitts and Nevis in 1976 to that in 1978?
Ensure brevity in your answer.  0.97. What is the ratio of the Official exchange rate (LCU per US$ period average) of Cabo Verde in 1976 to that in 1979?
Your answer should be compact. 0.81. What is the ratio of the Official exchange rate (LCU per US$ period average) in Maldives in 1976 to that in 1979?
Make the answer very short. 1.12. What is the ratio of the Official exchange rate (LCU per US$ period average) of St. Kitts and Nevis in 1976 to that in 1979?
Your answer should be compact. 0.97. What is the ratio of the Official exchange rate (LCU per US$ period average) of Cabo Verde in 1976 to that in 1980?
Make the answer very short. 0.75. What is the ratio of the Official exchange rate (LCU per US$ period average) of Maldives in 1976 to that in 1980?
Your response must be concise. 1.11. What is the ratio of the Official exchange rate (LCU per US$ period average) in St. Kitts and Nevis in 1976 to that in 1980?
Offer a very short reply. 0.97. What is the ratio of the Official exchange rate (LCU per US$ period average) of Cabo Verde in 1976 to that in 1981?
Offer a terse response. 0.62. What is the ratio of the Official exchange rate (LCU per US$ period average) in Maldives in 1976 to that in 1981?
Make the answer very short. 1.11. What is the ratio of the Official exchange rate (LCU per US$ period average) of St. Kitts and Nevis in 1976 to that in 1981?
Offer a terse response. 0.97. What is the ratio of the Official exchange rate (LCU per US$ period average) in Cabo Verde in 1976 to that in 1982?
Provide a short and direct response. 0.52. What is the ratio of the Official exchange rate (LCU per US$ period average) of Maldives in 1976 to that in 1982?
Give a very brief answer. 1.17. What is the ratio of the Official exchange rate (LCU per US$ period average) in St. Kitts and Nevis in 1976 to that in 1982?
Give a very brief answer. 0.97. What is the ratio of the Official exchange rate (LCU per US$ period average) in Cabo Verde in 1976 to that in 1983?
Your response must be concise. 0.42. What is the ratio of the Official exchange rate (LCU per US$ period average) of Maldives in 1976 to that in 1983?
Offer a terse response. 1.19. What is the ratio of the Official exchange rate (LCU per US$ period average) in St. Kitts and Nevis in 1976 to that in 1983?
Keep it short and to the point. 0.97. What is the ratio of the Official exchange rate (LCU per US$ period average) of Maldives in 1977 to that in 1978?
Your answer should be very brief. 0.98. What is the ratio of the Official exchange rate (LCU per US$ period average) in St. Kitts and Nevis in 1977 to that in 1978?
Provide a succinct answer. 1. What is the ratio of the Official exchange rate (LCU per US$ period average) of Cabo Verde in 1977 to that in 1979?
Offer a terse response. 0.91. What is the ratio of the Official exchange rate (LCU per US$ period average) in Maldives in 1977 to that in 1979?
Make the answer very short. 1.17. What is the ratio of the Official exchange rate (LCU per US$ period average) in St. Kitts and Nevis in 1977 to that in 1979?
Ensure brevity in your answer.  1. What is the ratio of the Official exchange rate (LCU per US$ period average) of Cabo Verde in 1977 to that in 1980?
Give a very brief answer. 0.85. What is the ratio of the Official exchange rate (LCU per US$ period average) in Maldives in 1977 to that in 1980?
Your answer should be compact. 1.16. What is the ratio of the Official exchange rate (LCU per US$ period average) of Cabo Verde in 1977 to that in 1981?
Ensure brevity in your answer.  0.7. What is the ratio of the Official exchange rate (LCU per US$ period average) of Maldives in 1977 to that in 1981?
Provide a short and direct response. 1.16. What is the ratio of the Official exchange rate (LCU per US$ period average) of St. Kitts and Nevis in 1977 to that in 1981?
Your answer should be compact. 1. What is the ratio of the Official exchange rate (LCU per US$ period average) in Cabo Verde in 1977 to that in 1982?
Your response must be concise. 0.58. What is the ratio of the Official exchange rate (LCU per US$ period average) in Maldives in 1977 to that in 1982?
Your response must be concise. 1.22. What is the ratio of the Official exchange rate (LCU per US$ period average) of St. Kitts and Nevis in 1977 to that in 1982?
Keep it short and to the point. 1. What is the ratio of the Official exchange rate (LCU per US$ period average) in Cabo Verde in 1977 to that in 1983?
Offer a very short reply. 0.47. What is the ratio of the Official exchange rate (LCU per US$ period average) of Maldives in 1977 to that in 1983?
Ensure brevity in your answer.  1.24. What is the ratio of the Official exchange rate (LCU per US$ period average) in Cabo Verde in 1978 to that in 1979?
Keep it short and to the point. 0.95. What is the ratio of the Official exchange rate (LCU per US$ period average) in Maldives in 1978 to that in 1979?
Your answer should be very brief. 1.2. What is the ratio of the Official exchange rate (LCU per US$ period average) in Cabo Verde in 1978 to that in 1980?
Keep it short and to the point. 0.88. What is the ratio of the Official exchange rate (LCU per US$ period average) in Maldives in 1978 to that in 1980?
Your answer should be very brief. 1.19. What is the ratio of the Official exchange rate (LCU per US$ period average) in St. Kitts and Nevis in 1978 to that in 1980?
Your answer should be very brief. 1. What is the ratio of the Official exchange rate (LCU per US$ period average) of Cabo Verde in 1978 to that in 1981?
Give a very brief answer. 0.73. What is the ratio of the Official exchange rate (LCU per US$ period average) in Maldives in 1978 to that in 1981?
Your answer should be very brief. 1.19. What is the ratio of the Official exchange rate (LCU per US$ period average) in Cabo Verde in 1978 to that in 1982?
Offer a terse response. 0.61. What is the ratio of the Official exchange rate (LCU per US$ period average) in Maldives in 1978 to that in 1982?
Offer a terse response. 1.25. What is the ratio of the Official exchange rate (LCU per US$ period average) of St. Kitts and Nevis in 1978 to that in 1982?
Make the answer very short. 1. What is the ratio of the Official exchange rate (LCU per US$ period average) of Cabo Verde in 1978 to that in 1983?
Give a very brief answer. 0.5. What is the ratio of the Official exchange rate (LCU per US$ period average) in Maldives in 1978 to that in 1983?
Make the answer very short. 1.27. What is the ratio of the Official exchange rate (LCU per US$ period average) of Cabo Verde in 1979 to that in 1980?
Your response must be concise. 0.93. What is the ratio of the Official exchange rate (LCU per US$ period average) of Maldives in 1979 to that in 1980?
Give a very brief answer. 0.99. What is the ratio of the Official exchange rate (LCU per US$ period average) in St. Kitts and Nevis in 1979 to that in 1980?
Make the answer very short. 1. What is the ratio of the Official exchange rate (LCU per US$ period average) of Cabo Verde in 1979 to that in 1981?
Offer a very short reply. 0.77. What is the ratio of the Official exchange rate (LCU per US$ period average) of St. Kitts and Nevis in 1979 to that in 1981?
Make the answer very short. 1. What is the ratio of the Official exchange rate (LCU per US$ period average) of Cabo Verde in 1979 to that in 1982?
Provide a short and direct response. 0.64. What is the ratio of the Official exchange rate (LCU per US$ period average) in Maldives in 1979 to that in 1982?
Make the answer very short. 1.04. What is the ratio of the Official exchange rate (LCU per US$ period average) of Cabo Verde in 1979 to that in 1983?
Provide a short and direct response. 0.52. What is the ratio of the Official exchange rate (LCU per US$ period average) of Maldives in 1979 to that in 1983?
Offer a terse response. 1.06. What is the ratio of the Official exchange rate (LCU per US$ period average) in St. Kitts and Nevis in 1979 to that in 1983?
Make the answer very short. 1. What is the ratio of the Official exchange rate (LCU per US$ period average) of Cabo Verde in 1980 to that in 1981?
Your answer should be compact. 0.82. What is the ratio of the Official exchange rate (LCU per US$ period average) in Maldives in 1980 to that in 1981?
Provide a short and direct response. 1. What is the ratio of the Official exchange rate (LCU per US$ period average) of St. Kitts and Nevis in 1980 to that in 1981?
Offer a very short reply. 1. What is the ratio of the Official exchange rate (LCU per US$ period average) in Cabo Verde in 1980 to that in 1982?
Give a very brief answer. 0.69. What is the ratio of the Official exchange rate (LCU per US$ period average) in Maldives in 1980 to that in 1982?
Give a very brief answer. 1.05. What is the ratio of the Official exchange rate (LCU per US$ period average) of Cabo Verde in 1980 to that in 1983?
Your answer should be compact. 0.56. What is the ratio of the Official exchange rate (LCU per US$ period average) in Maldives in 1980 to that in 1983?
Offer a terse response. 1.07. What is the ratio of the Official exchange rate (LCU per US$ period average) in St. Kitts and Nevis in 1980 to that in 1983?
Your answer should be compact. 1. What is the ratio of the Official exchange rate (LCU per US$ period average) of Cabo Verde in 1981 to that in 1982?
Your response must be concise. 0.84. What is the ratio of the Official exchange rate (LCU per US$ period average) in Maldives in 1981 to that in 1982?
Offer a very short reply. 1.05. What is the ratio of the Official exchange rate (LCU per US$ period average) of St. Kitts and Nevis in 1981 to that in 1982?
Make the answer very short. 1. What is the ratio of the Official exchange rate (LCU per US$ period average) of Cabo Verde in 1981 to that in 1983?
Offer a very short reply. 0.68. What is the ratio of the Official exchange rate (LCU per US$ period average) of Maldives in 1981 to that in 1983?
Offer a very short reply. 1.07. What is the ratio of the Official exchange rate (LCU per US$ period average) of Cabo Verde in 1982 to that in 1983?
Make the answer very short. 0.81. What is the ratio of the Official exchange rate (LCU per US$ period average) in Maldives in 1982 to that in 1983?
Your answer should be very brief. 1.02. What is the ratio of the Official exchange rate (LCU per US$ period average) of St. Kitts and Nevis in 1982 to that in 1983?
Provide a succinct answer. 1. What is the difference between the highest and the second highest Official exchange rate (LCU per US$ period average) of Cabo Verde?
Make the answer very short. 13.39. What is the difference between the highest and the second highest Official exchange rate (LCU per US$ period average) in Maldives?
Your response must be concise. 0.2. What is the difference between the highest and the second highest Official exchange rate (LCU per US$ period average) of St. Kitts and Nevis?
Keep it short and to the point. 0. What is the difference between the highest and the lowest Official exchange rate (LCU per US$ period average) in Cabo Verde?
Make the answer very short. 41.46. What is the difference between the highest and the lowest Official exchange rate (LCU per US$ period average) in Maldives?
Your response must be concise. 1.92. What is the difference between the highest and the lowest Official exchange rate (LCU per US$ period average) of St. Kitts and Nevis?
Keep it short and to the point. 0.09. 